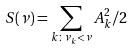Convert formula to latex. <formula><loc_0><loc_0><loc_500><loc_500>S ( \nu ) = \sum _ { k \colon \nu _ { k } < \nu } A _ { k } ^ { 2 } / 2</formula> 